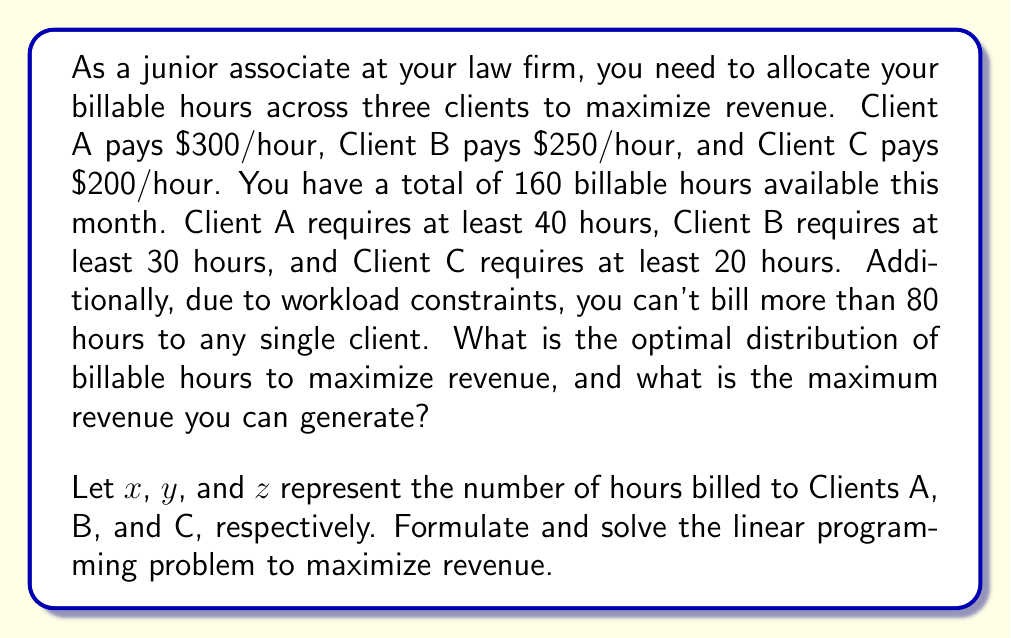Show me your answer to this math problem. To solve this optimization problem, we'll use linear programming. Let's formulate the problem:

Objective function (maximize revenue):
$$\text{Maximize } 300x + 250y + 200z$$

Constraints:
1. Total available hours: $x + y + z \leq 160$
2. Minimum hours for Client A: $x \geq 40$
3. Minimum hours for Client B: $y \geq 30$
4. Minimum hours for Client C: $z \geq 20$
5. Maximum hours per client: $x \leq 80$, $y \leq 80$, $z \leq 80$
6. Non-negativity: $x, y, z \geq 0$

To solve this, we'll use the simplex method or a linear programming solver. However, we can also reason through the solution:

1. Since Client A pays the highest rate, we should allocate the maximum possible hours to them: 80 hours.
2. Client B has the second-highest rate, so we allocate the maximum remaining hours to them: $\min(80, 160-80) = 80$ hours.
3. The remaining hours go to Client C: $160 - 80 - 80 = 0$ hours.

This allocation satisfies all constraints:
- Total hours: $80 + 80 + 0 = 160$
- Minimum hours for each client are met
- Maximum hours per client (80) is not exceeded

The maximum revenue is:
$$(300 \times 80) + (250 \times 80) + (200 \times 0) = 24,000 + 20,000 + 0 = \$44,000$$
Answer: The optimal distribution of billable hours is 80 hours for Client A, 80 hours for Client B, and 0 hours for Client C. The maximum revenue that can be generated is $44,000. 